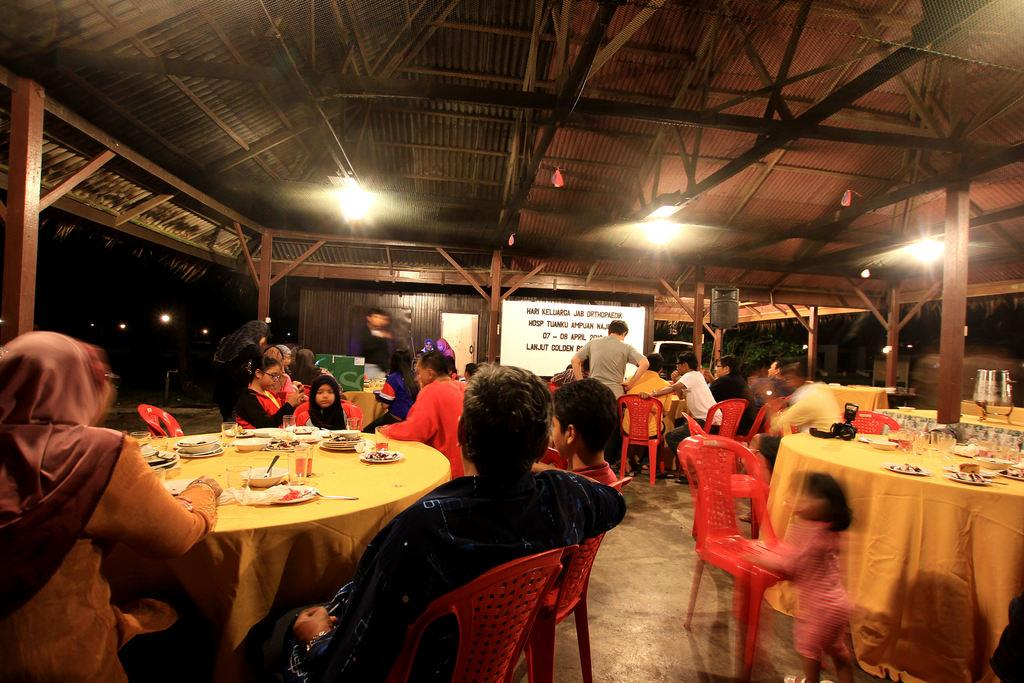What are the people in the image doing? The people in the image are sitting on chairs. How are the chairs arranged in the image? The chairs are arranged around a dining table. What can be seen above the dining table in the image? There is a light on top, likely above the dining table. What type of honey is being served on the table in the image? There is no honey present on the table in the image. What season is it in the image, considering the presence of winter clothing? There is no indication of winter clothing or any specific season in the image. 